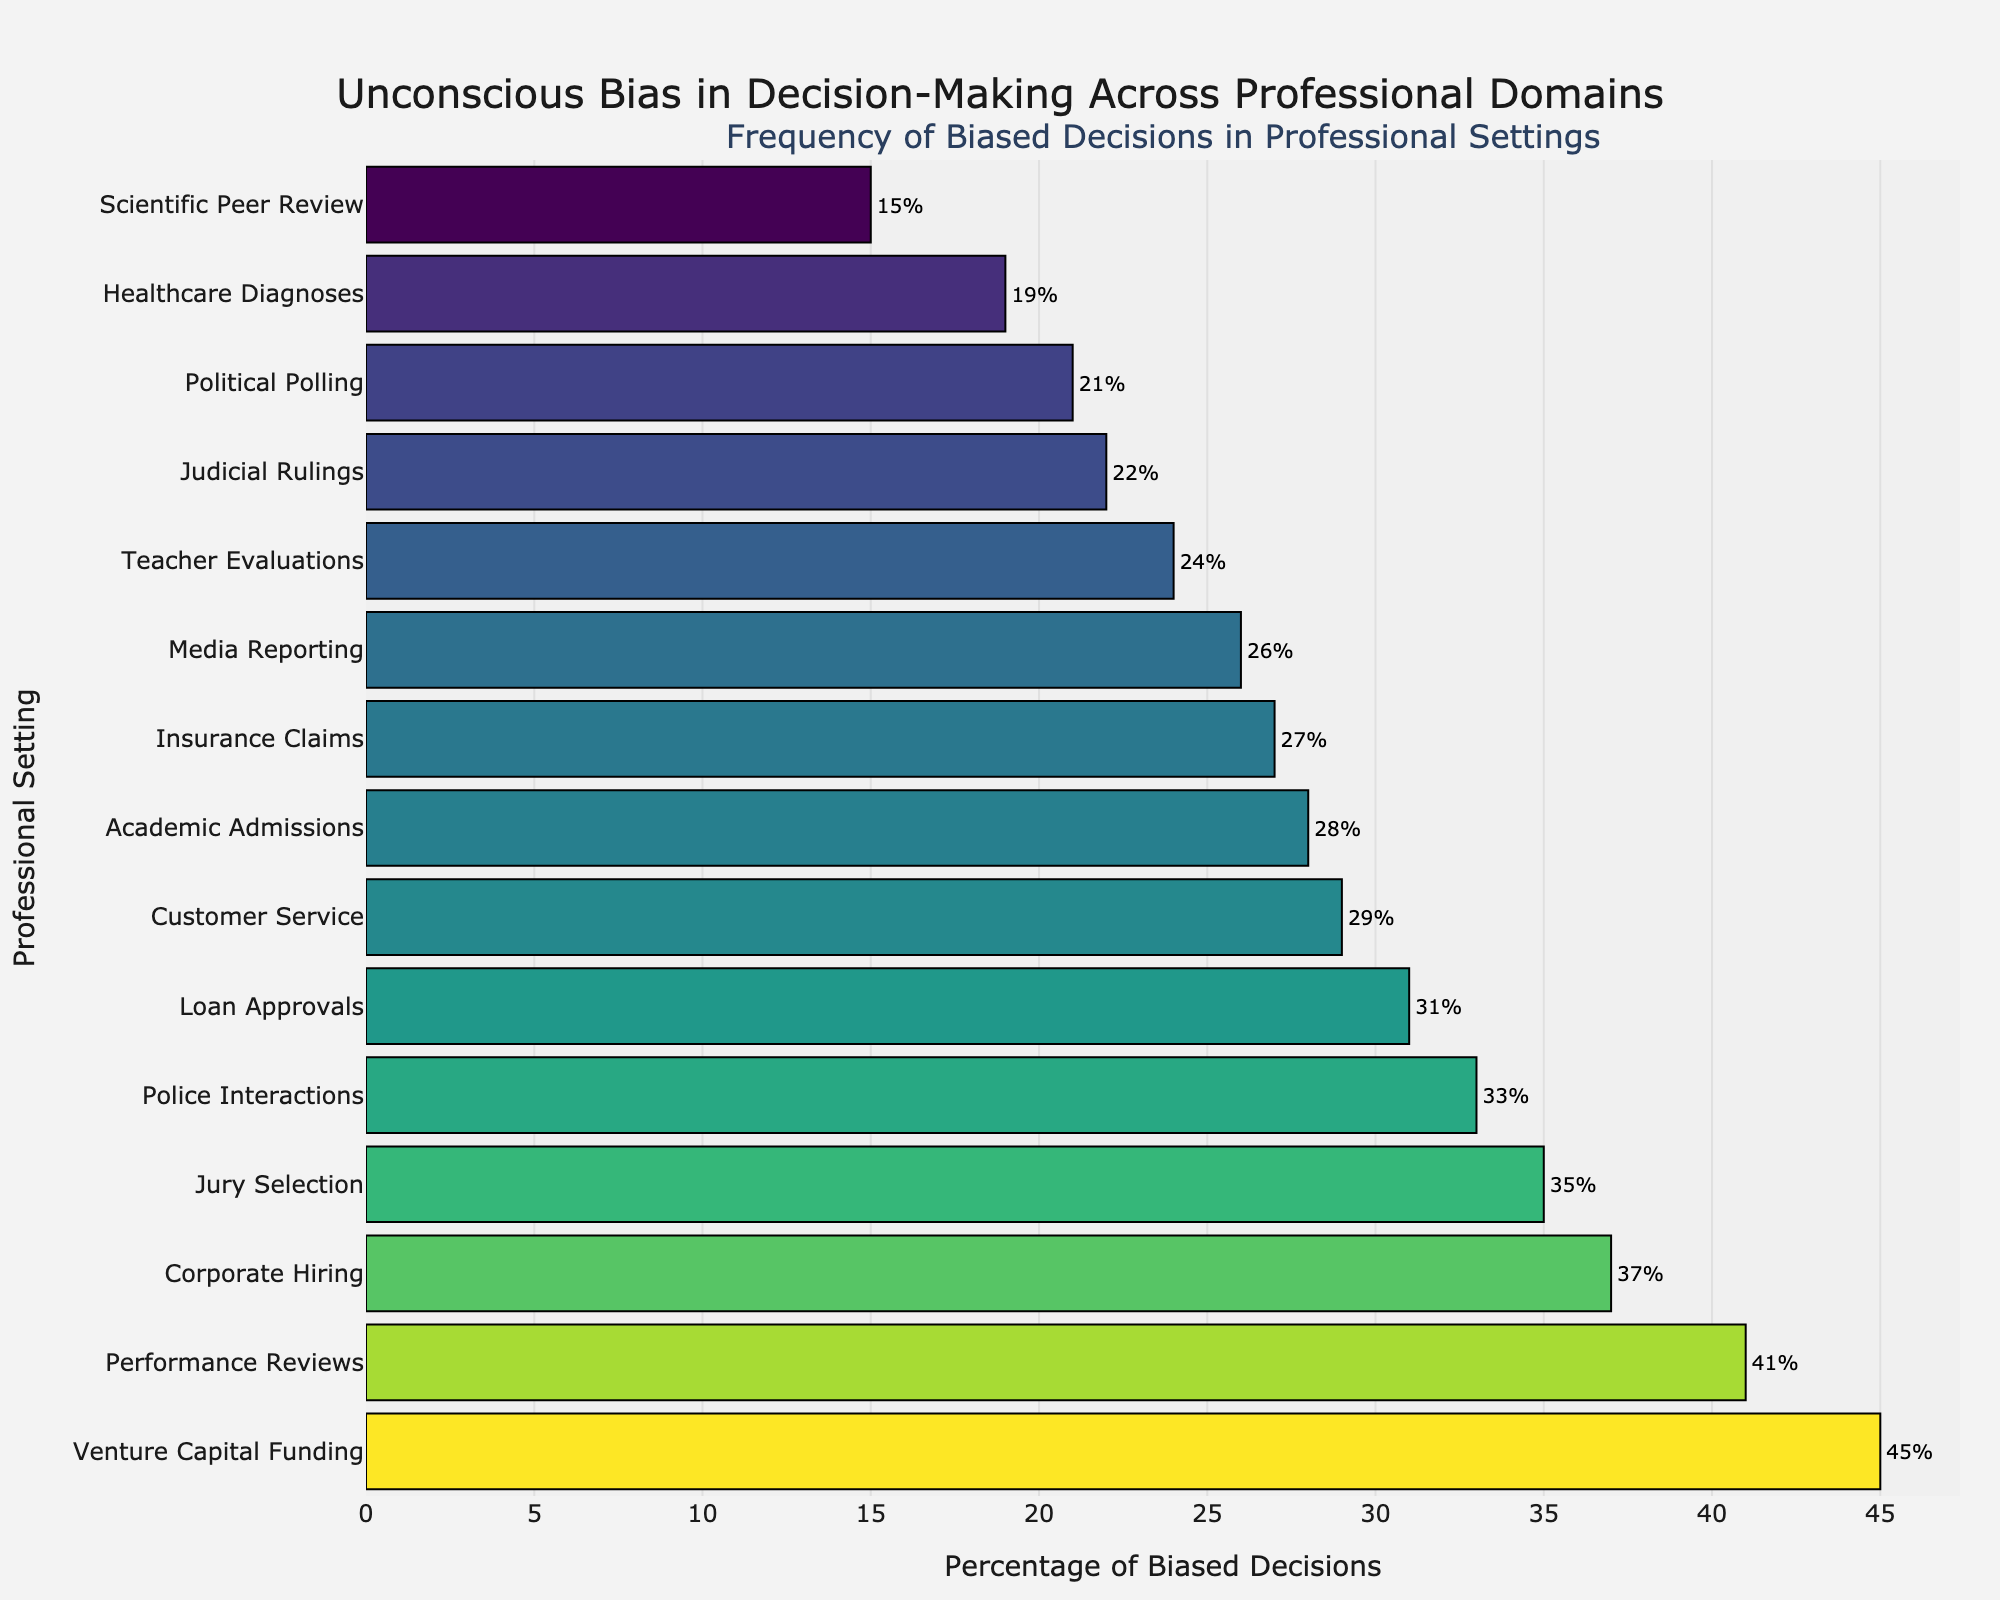Which professional setting has the highest percentage of biased decisions? The longest bar visually indicates the highest percentage. The bar for "Venture Capital Funding" is the longest.
Answer: Venture Capital Funding Which professional setting has the lowest percentage of biased decisions? The shortest bar represents the lowest percentage. The bar for "Scientific Peer Review" is the shortest.
Answer: Scientific Peer Review What is the difference in the percentage of biased decisions between the highest and lowest professional settings? The highest percentage is 45% (Venture Capital Funding) and the lowest is 15% (Scientific Peer Review). The difference is calculated as 45% - 15%.
Answer: 30% How many professional settings have a percentage of biased decisions greater than 30%? By examining the lengths of the bars, count the number of settings with bars extending beyond the 30% mark. These settings are Corporate Hiring, Venture Capital Funding, Performance Reviews, Police Interactions, Loan Approvals, and Jury Selection.
Answer: 6 What is the average percentage of biased decisions across all settings? Sum the percentages (37 + 28 + 22 + 19 + 41 + 45 + 33 + 31 + 26 + 15 + 24 + 29 + 21 + 35 + 27) = 432. There are 15 settings, so divide the total by 15.
Answer: 28.8% Which setting has a percentage closest to the average percentage of biased decisions? The average percentage is 28.8%. Compare each setting's percentage to this value. "Academic Admissions" has 28%, which is closest to 28.8%.
Answer: Academic Admissions How does the percentage of biased decisions in Corporate Hiring compare to that in Teacher Evaluations? Corporate Hiring has 37% and Teacher Evaluations have 24%. Subtract 24% from 37% to find the difference.
Answer: 13% What is the combined percentage of biased decisions for Media Reporting and Healthcare Diagnoses? Add the percentages for each setting: Media Reporting (26%) + Healthcare Diagnoses (19%).
Answer: 45% What is the median percentage of biased decisions among the settings? Sort the percentages and find the middle value. Sorted: 15, 19, 21, 22, 24, 26, 27, 28, 29, 31, 33, 35, 37, 41, 45. The median is the 8th value (28%).
Answer: 28% Which professional setting has a bias level categorized as "High" based on the color bar? The color bar categorizes bias levels, and "High" corresponds to percentages around 40%. "Venture Capital Funding" at 45% and "Performance Reviews" at 41% fit this category.
Answer: Venture Capital Funding, Performance Reviews 